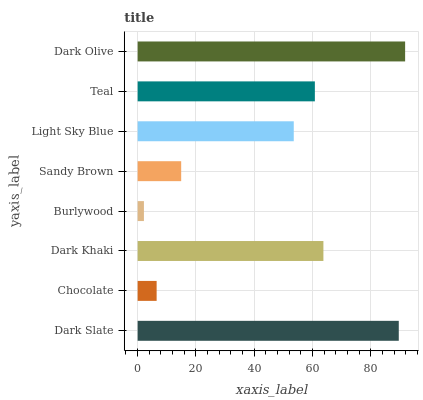Is Burlywood the minimum?
Answer yes or no. Yes. Is Dark Olive the maximum?
Answer yes or no. Yes. Is Chocolate the minimum?
Answer yes or no. No. Is Chocolate the maximum?
Answer yes or no. No. Is Dark Slate greater than Chocolate?
Answer yes or no. Yes. Is Chocolate less than Dark Slate?
Answer yes or no. Yes. Is Chocolate greater than Dark Slate?
Answer yes or no. No. Is Dark Slate less than Chocolate?
Answer yes or no. No. Is Teal the high median?
Answer yes or no. Yes. Is Light Sky Blue the low median?
Answer yes or no. Yes. Is Dark Olive the high median?
Answer yes or no. No. Is Sandy Brown the low median?
Answer yes or no. No. 